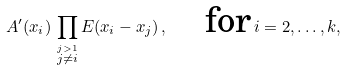Convert formula to latex. <formula><loc_0><loc_0><loc_500><loc_500>A ^ { \prime } ( x _ { i } ) \, \prod _ { \stackrel { j > 1 } { j \neq i } } E ( x _ { i } - x _ { j } ) \, , \quad \text {for} \, i = 2 , \dots , k ,</formula> 